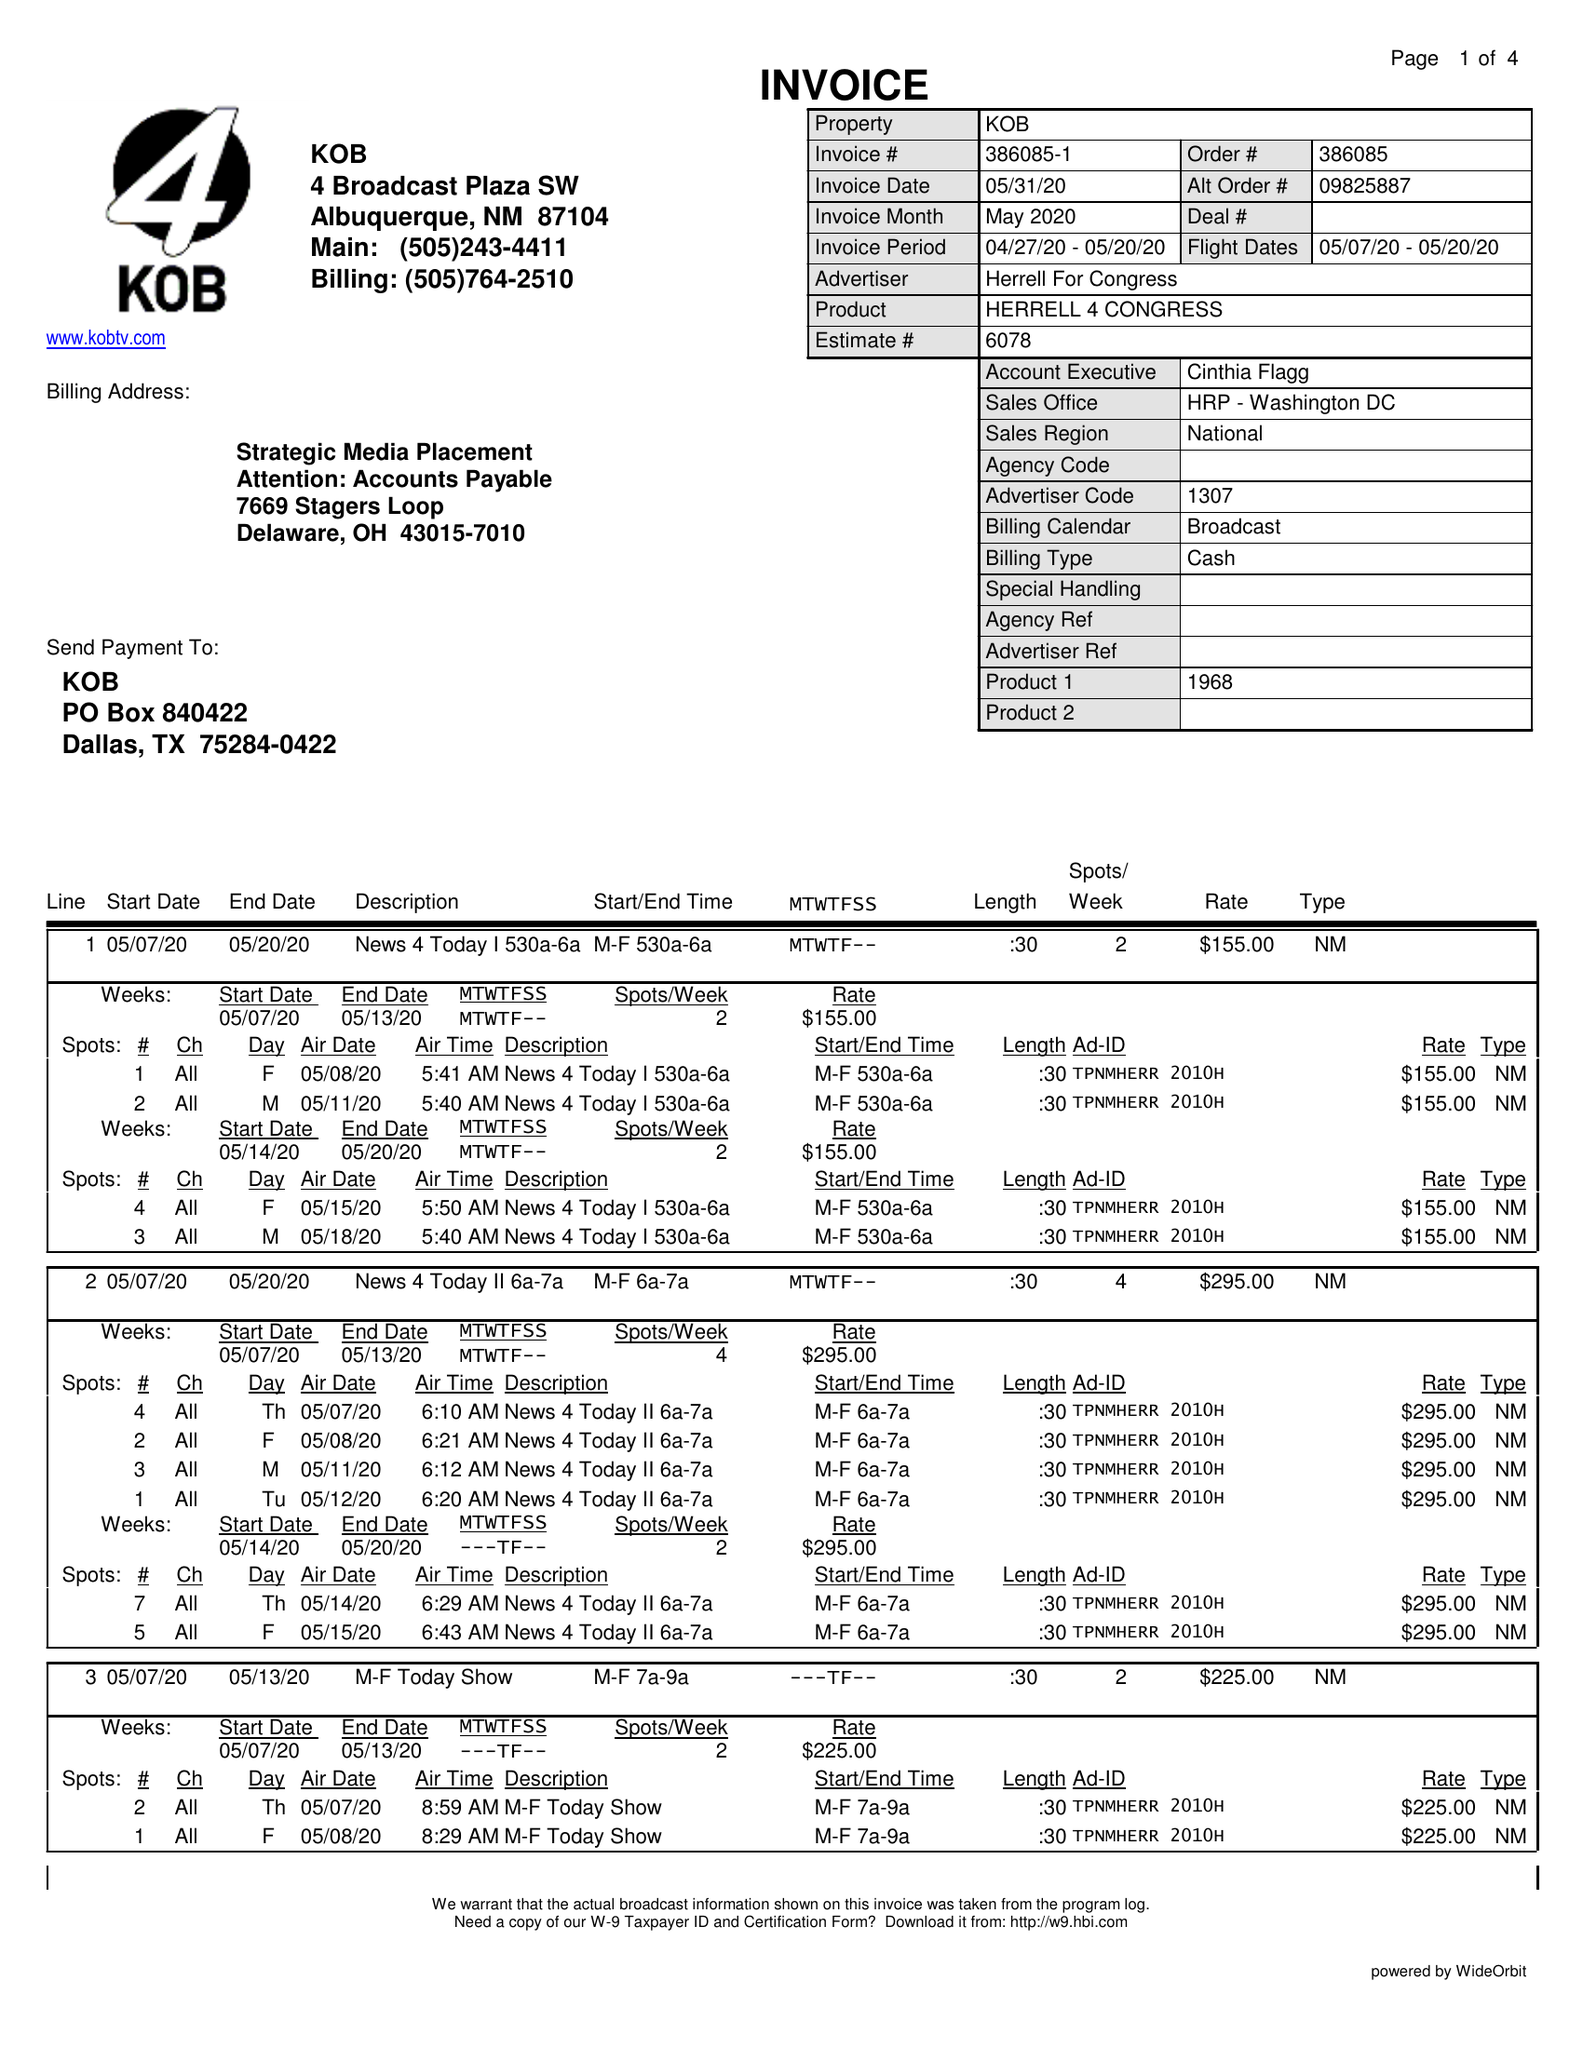What is the value for the flight_to?
Answer the question using a single word or phrase. 05/20/20 